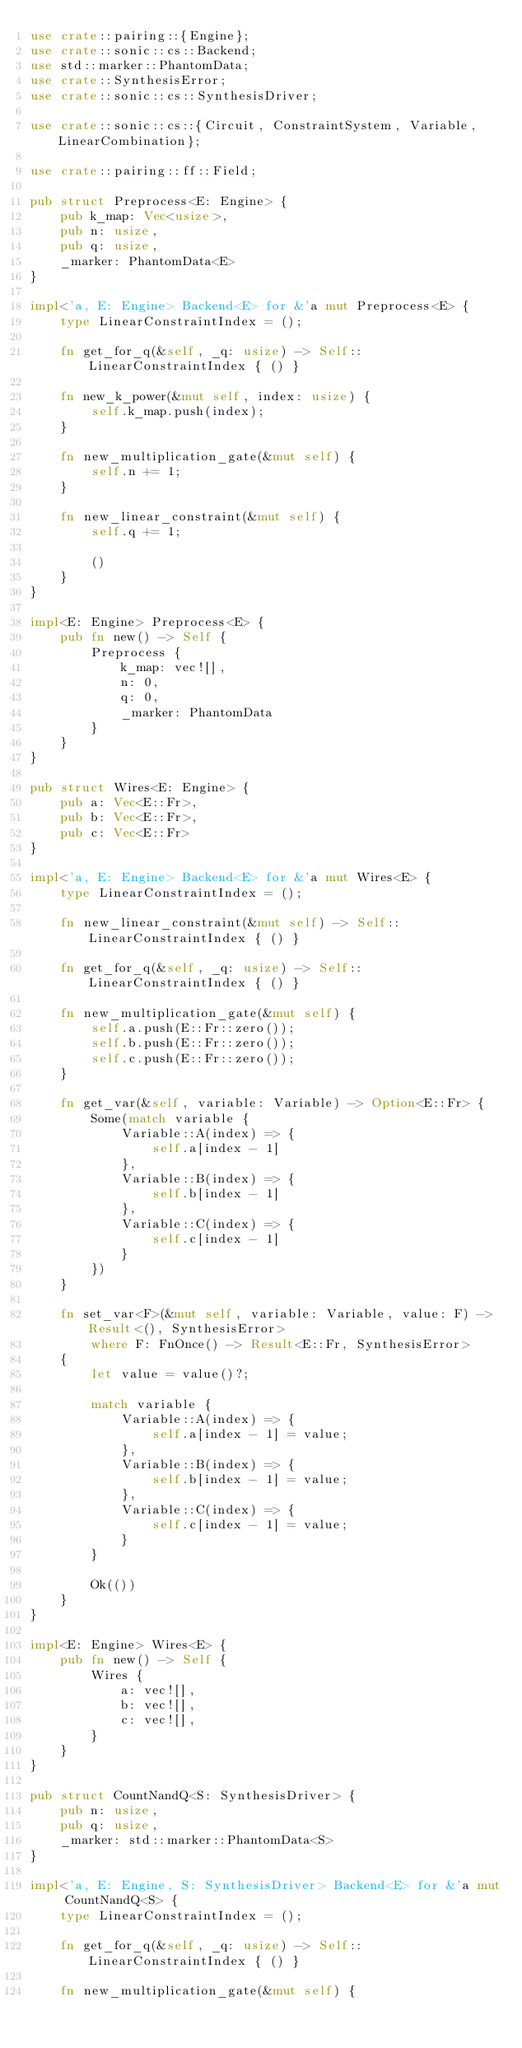<code> <loc_0><loc_0><loc_500><loc_500><_Rust_>use crate::pairing::{Engine};
use crate::sonic::cs::Backend;
use std::marker::PhantomData;
use crate::SynthesisError;
use crate::sonic::cs::SynthesisDriver;

use crate::sonic::cs::{Circuit, ConstraintSystem, Variable, LinearCombination};

use crate::pairing::ff::Field;

pub struct Preprocess<E: Engine> {
    pub k_map: Vec<usize>,
    pub n: usize,
    pub q: usize,
    _marker: PhantomData<E>
}

impl<'a, E: Engine> Backend<E> for &'a mut Preprocess<E> {
    type LinearConstraintIndex = ();

    fn get_for_q(&self, _q: usize) -> Self::LinearConstraintIndex { () }

    fn new_k_power(&mut self, index: usize) {
        self.k_map.push(index);
    }

    fn new_multiplication_gate(&mut self) {
        self.n += 1;
    }

    fn new_linear_constraint(&mut self) {
        self.q += 1;

        ()
    }
}

impl<E: Engine> Preprocess<E> {
    pub fn new() -> Self {
        Preprocess { 
            k_map: vec![], 
            n: 0, 
            q: 0, 
            _marker: PhantomData 
        }
    }
}

pub struct Wires<E: Engine> {
    pub a: Vec<E::Fr>,
    pub b: Vec<E::Fr>,
    pub c: Vec<E::Fr>
}

impl<'a, E: Engine> Backend<E> for &'a mut Wires<E> {
    type LinearConstraintIndex = ();

    fn new_linear_constraint(&mut self) -> Self::LinearConstraintIndex { () }

    fn get_for_q(&self, _q: usize) -> Self::LinearConstraintIndex { () }

    fn new_multiplication_gate(&mut self) {
        self.a.push(E::Fr::zero());
        self.b.push(E::Fr::zero());
        self.c.push(E::Fr::zero());
    }

    fn get_var(&self, variable: Variable) -> Option<E::Fr> {
        Some(match variable {
            Variable::A(index) => {
                self.a[index - 1]
            },
            Variable::B(index) => {
                self.b[index - 1]
            },
            Variable::C(index) => {
                self.c[index - 1]
            }
        })
    }

    fn set_var<F>(&mut self, variable: Variable, value: F) -> Result<(), SynthesisError>
        where F: FnOnce() -> Result<E::Fr, SynthesisError>
    {
        let value = value()?;

        match variable {
            Variable::A(index) => {
                self.a[index - 1] = value;
            },
            Variable::B(index) => {
                self.b[index - 1] = value;
            },
            Variable::C(index) => {
                self.c[index - 1] = value;
            }
        }

        Ok(())
    }
}

impl<E: Engine> Wires<E> {
    pub fn new() -> Self {
        Wires {
            a: vec![],
            b: vec![],
            c: vec![],
        }
    }
}

pub struct CountNandQ<S: SynthesisDriver> {
    pub n: usize,
    pub q: usize,
    _marker: std::marker::PhantomData<S>
}

impl<'a, E: Engine, S: SynthesisDriver> Backend<E> for &'a mut CountNandQ<S> {
    type LinearConstraintIndex = ();

    fn get_for_q(&self, _q: usize) -> Self::LinearConstraintIndex { () }

    fn new_multiplication_gate(&mut self) {</code> 